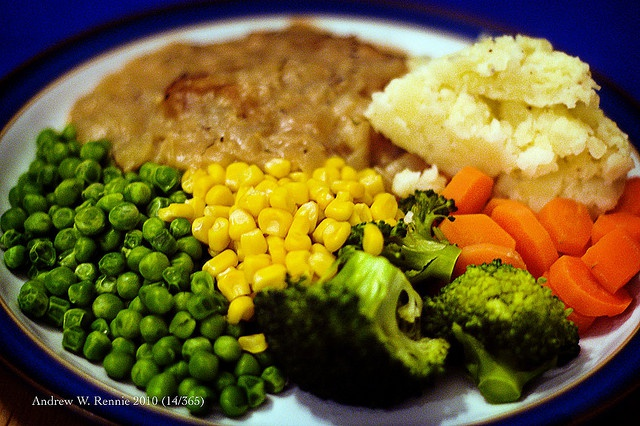Describe the objects in this image and their specific colors. I can see broccoli in navy, black, and olive tones, broccoli in navy, black, olive, and darkgreen tones, carrot in navy, red, brown, and maroon tones, broccoli in navy, black, olive, and gold tones, and carrot in navy, red, brown, and orange tones in this image. 